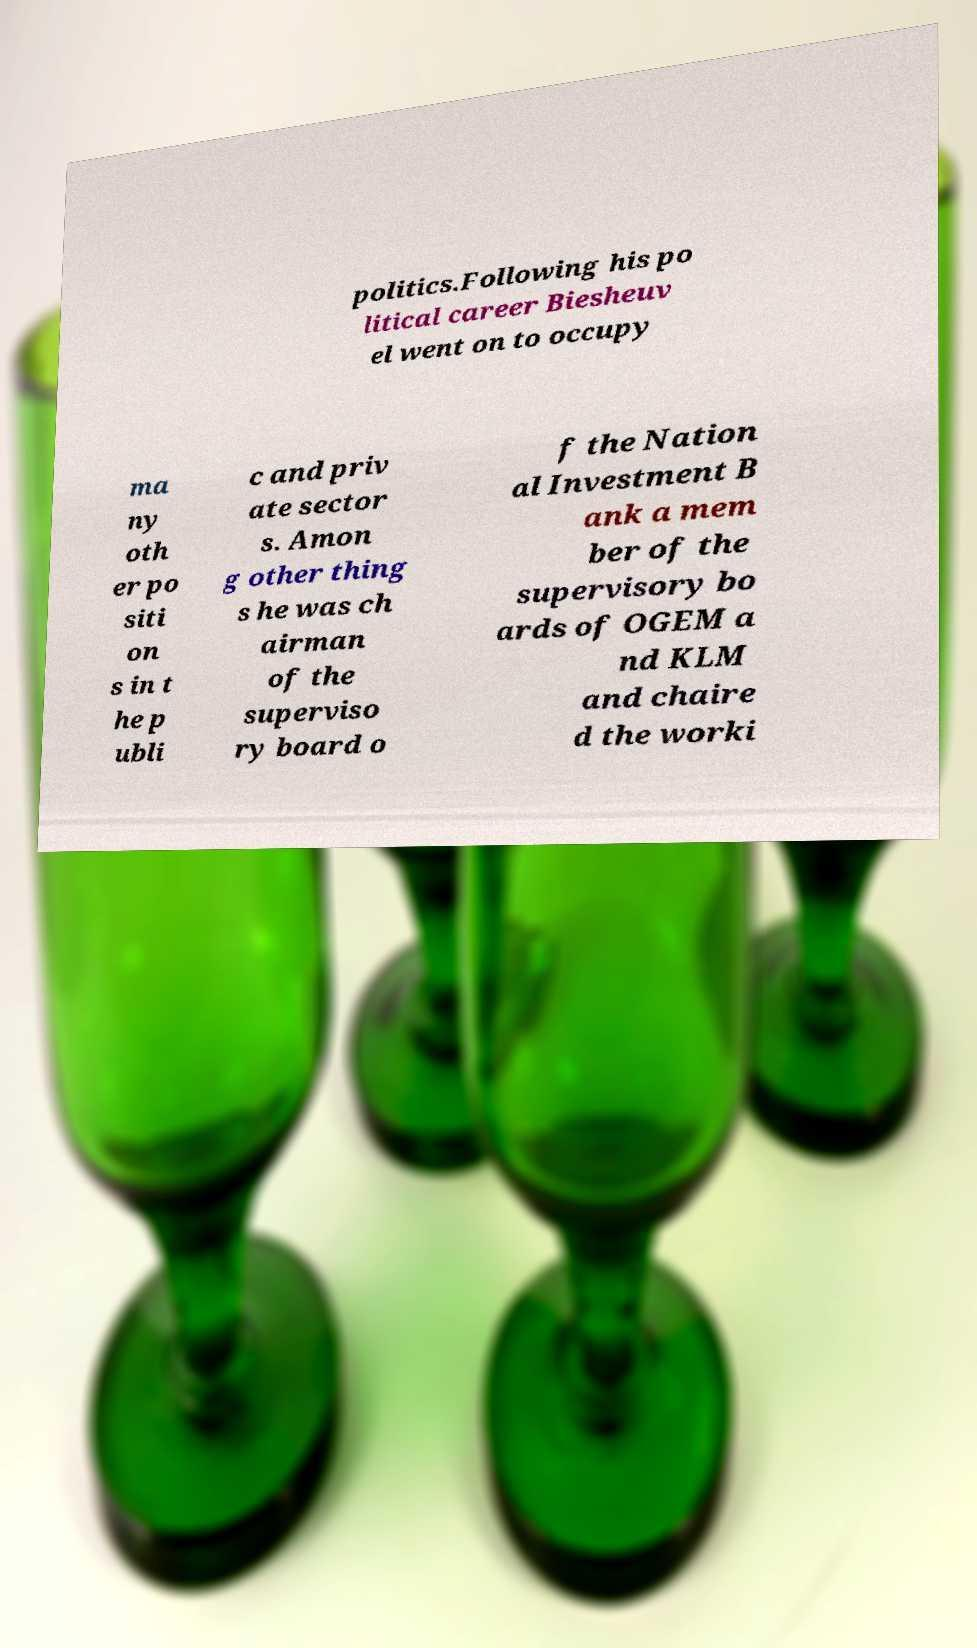Could you extract and type out the text from this image? politics.Following his po litical career Biesheuv el went on to occupy ma ny oth er po siti on s in t he p ubli c and priv ate sector s. Amon g other thing s he was ch airman of the superviso ry board o f the Nation al Investment B ank a mem ber of the supervisory bo ards of OGEM a nd KLM and chaire d the worki 